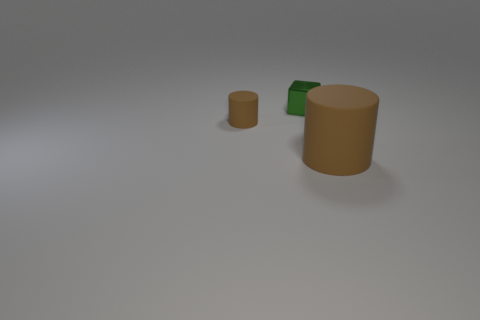Add 3 large brown things. How many objects exist? 6 Subtract all blocks. How many objects are left? 2 Add 2 tiny brown objects. How many tiny brown objects are left? 3 Add 2 big brown rubber objects. How many big brown rubber objects exist? 3 Subtract 0 brown spheres. How many objects are left? 3 Subtract all small brown metal balls. Subtract all large cylinders. How many objects are left? 2 